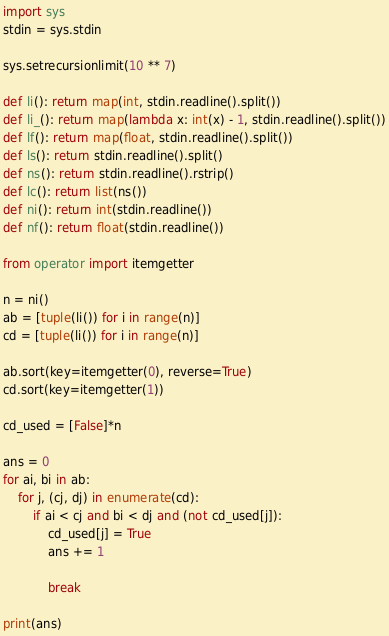<code> <loc_0><loc_0><loc_500><loc_500><_Python_>import sys
stdin = sys.stdin

sys.setrecursionlimit(10 ** 7)

def li(): return map(int, stdin.readline().split())
def li_(): return map(lambda x: int(x) - 1, stdin.readline().split())
def lf(): return map(float, stdin.readline().split())
def ls(): return stdin.readline().split()
def ns(): return stdin.readline().rstrip()
def lc(): return list(ns())
def ni(): return int(stdin.readline())
def nf(): return float(stdin.readline())

from operator import itemgetter

n = ni()
ab = [tuple(li()) for i in range(n)]
cd = [tuple(li()) for i in range(n)]

ab.sort(key=itemgetter(0), reverse=True)
cd.sort(key=itemgetter(1))

cd_used = [False]*n

ans = 0
for ai, bi in ab:
    for j, (cj, dj) in enumerate(cd):
        if ai < cj and bi < dj and (not cd_used[j]):
            cd_used[j] = True
            ans += 1

            break

print(ans)</code> 